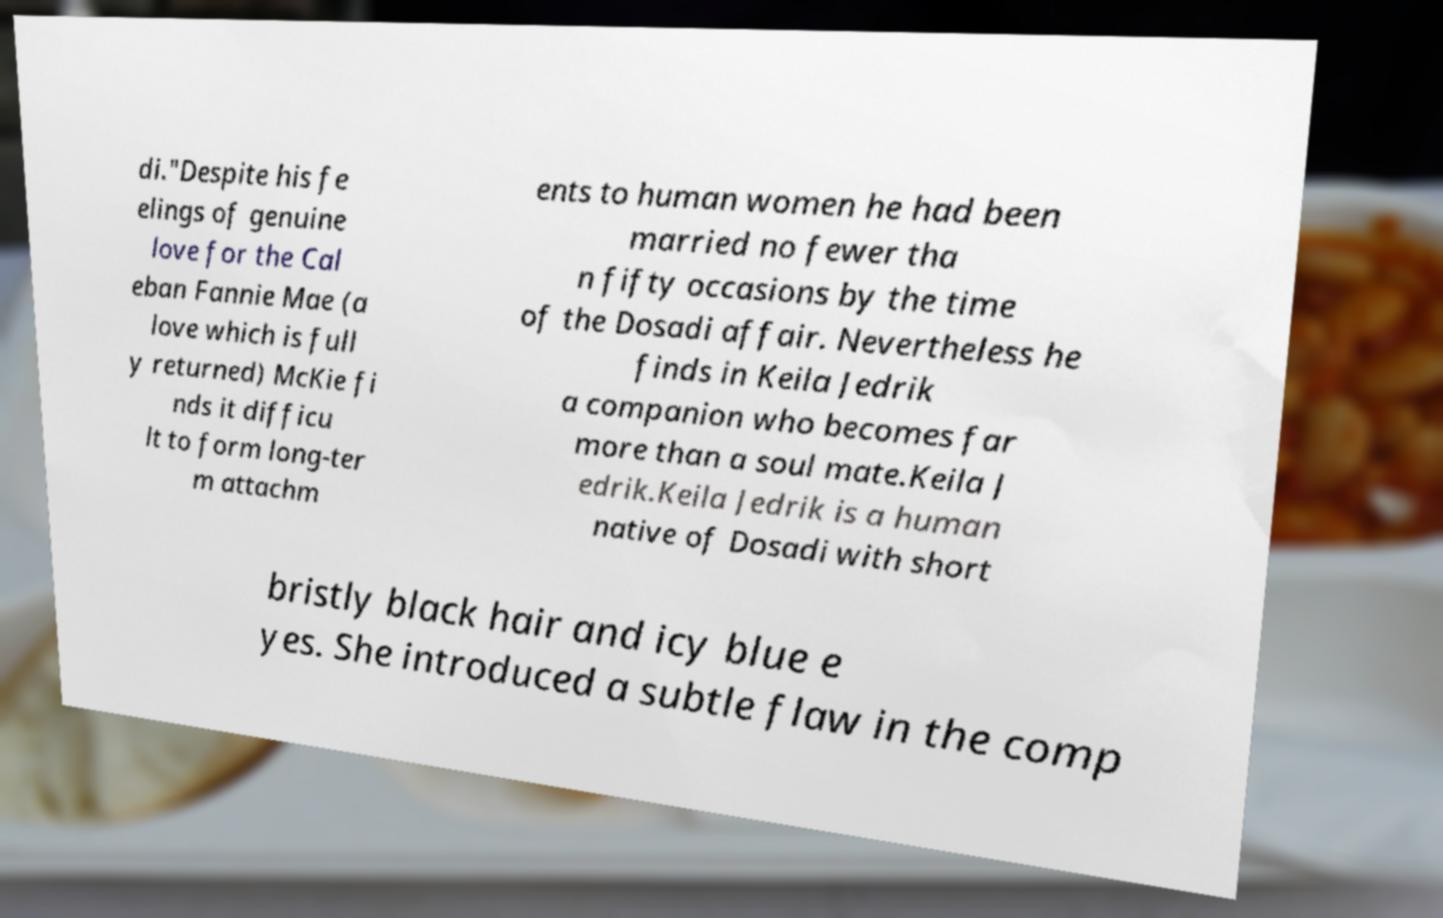Please identify and transcribe the text found in this image. di."Despite his fe elings of genuine love for the Cal eban Fannie Mae (a love which is full y returned) McKie fi nds it difficu lt to form long-ter m attachm ents to human women he had been married no fewer tha n fifty occasions by the time of the Dosadi affair. Nevertheless he finds in Keila Jedrik a companion who becomes far more than a soul mate.Keila J edrik.Keila Jedrik is a human native of Dosadi with short bristly black hair and icy blue e yes. She introduced a subtle flaw in the comp 